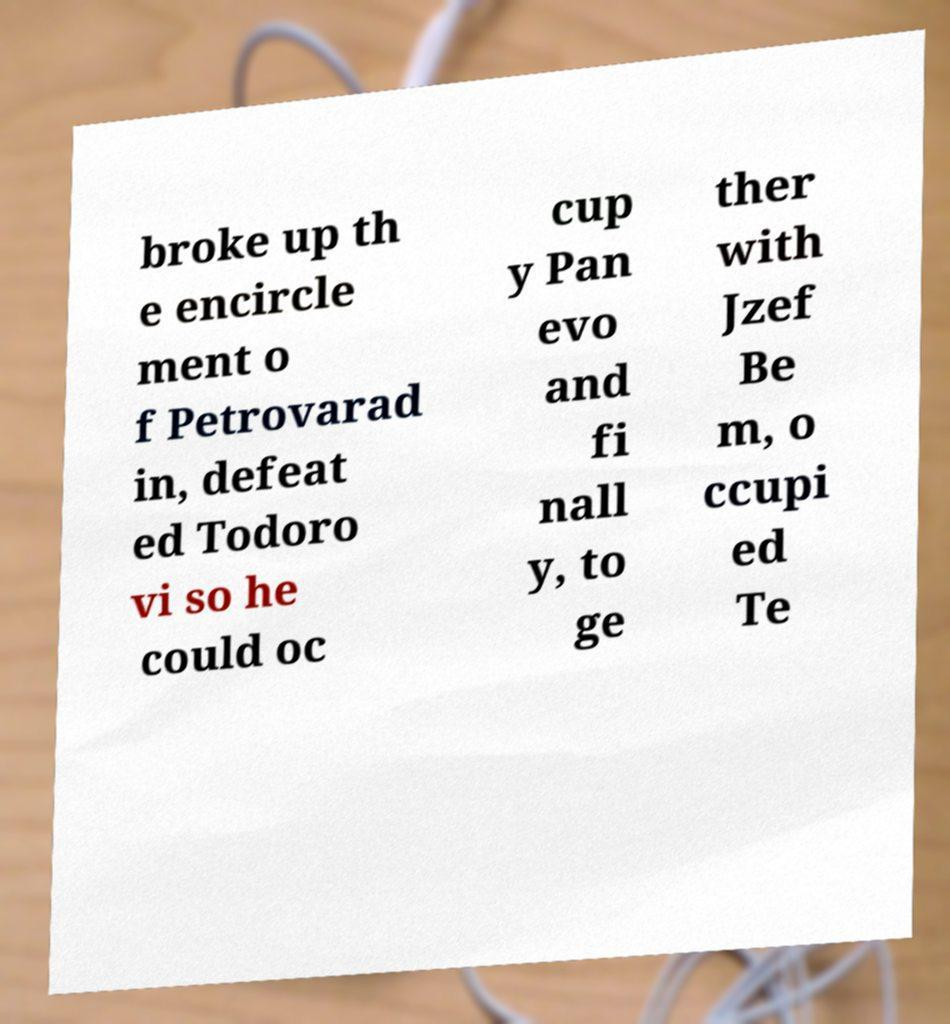Can you read and provide the text displayed in the image?This photo seems to have some interesting text. Can you extract and type it out for me? broke up th e encircle ment o f Petrovarad in, defeat ed Todoro vi so he could oc cup y Pan evo and fi nall y, to ge ther with Jzef Be m, o ccupi ed Te 